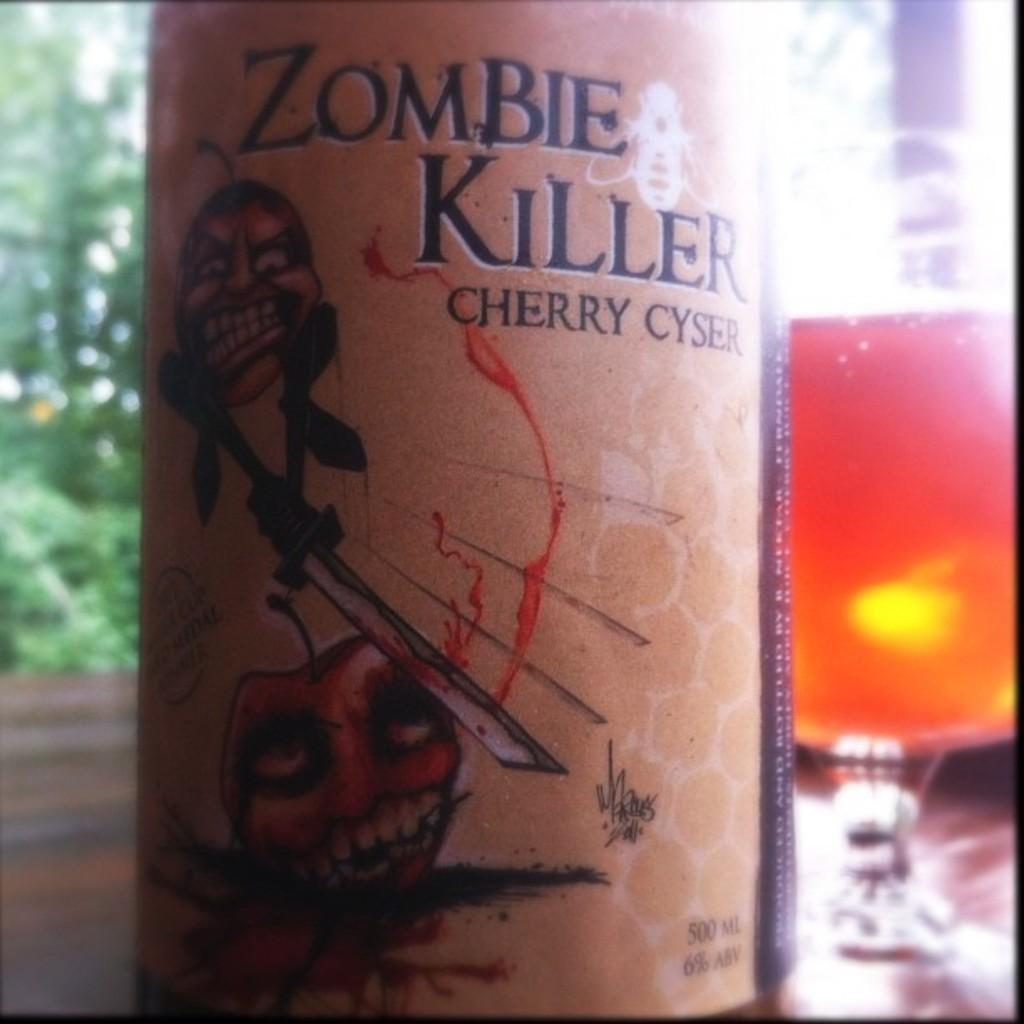What objects are on the table in the image? There is a bottle and a glass on the table in the image. Can you describe the background of the image? The background of the image is blurred. What activity is taking place at the gate in the image? There is no gate present in the image, so no activity can be observed at a gate. What type of lipstick is the person wearing in the image? There is no person or lipstick present in the image. 